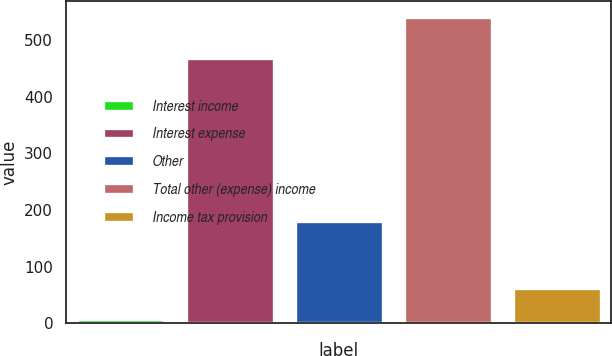Convert chart to OTSL. <chart><loc_0><loc_0><loc_500><loc_500><bar_chart><fcel>Interest income<fcel>Interest expense<fcel>Other<fcel>Total other (expense) income<fcel>Income tax provision<nl><fcel>8<fcel>469<fcel>180<fcel>542<fcel>61.4<nl></chart> 